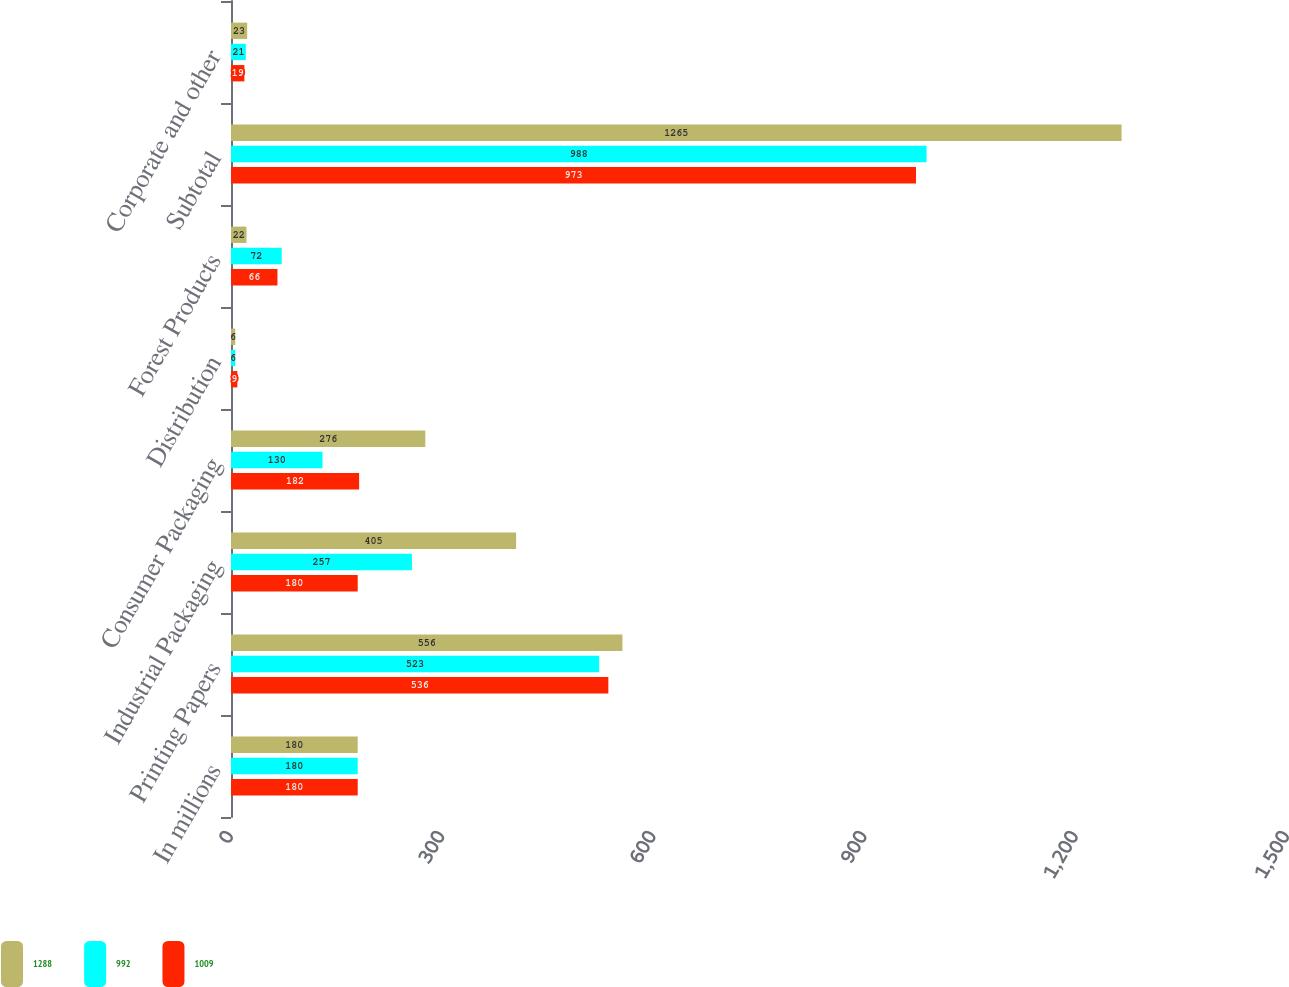<chart> <loc_0><loc_0><loc_500><loc_500><stacked_bar_chart><ecel><fcel>In millions<fcel>Printing Papers<fcel>Industrial Packaging<fcel>Consumer Packaging<fcel>Distribution<fcel>Forest Products<fcel>Subtotal<fcel>Corporate and other<nl><fcel>1288<fcel>180<fcel>556<fcel>405<fcel>276<fcel>6<fcel>22<fcel>1265<fcel>23<nl><fcel>992<fcel>180<fcel>523<fcel>257<fcel>130<fcel>6<fcel>72<fcel>988<fcel>21<nl><fcel>1009<fcel>180<fcel>536<fcel>180<fcel>182<fcel>9<fcel>66<fcel>973<fcel>19<nl></chart> 